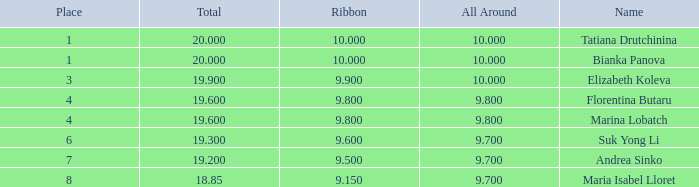What place had a ribbon below 9.8 and a 19.2 total? 7.0. 